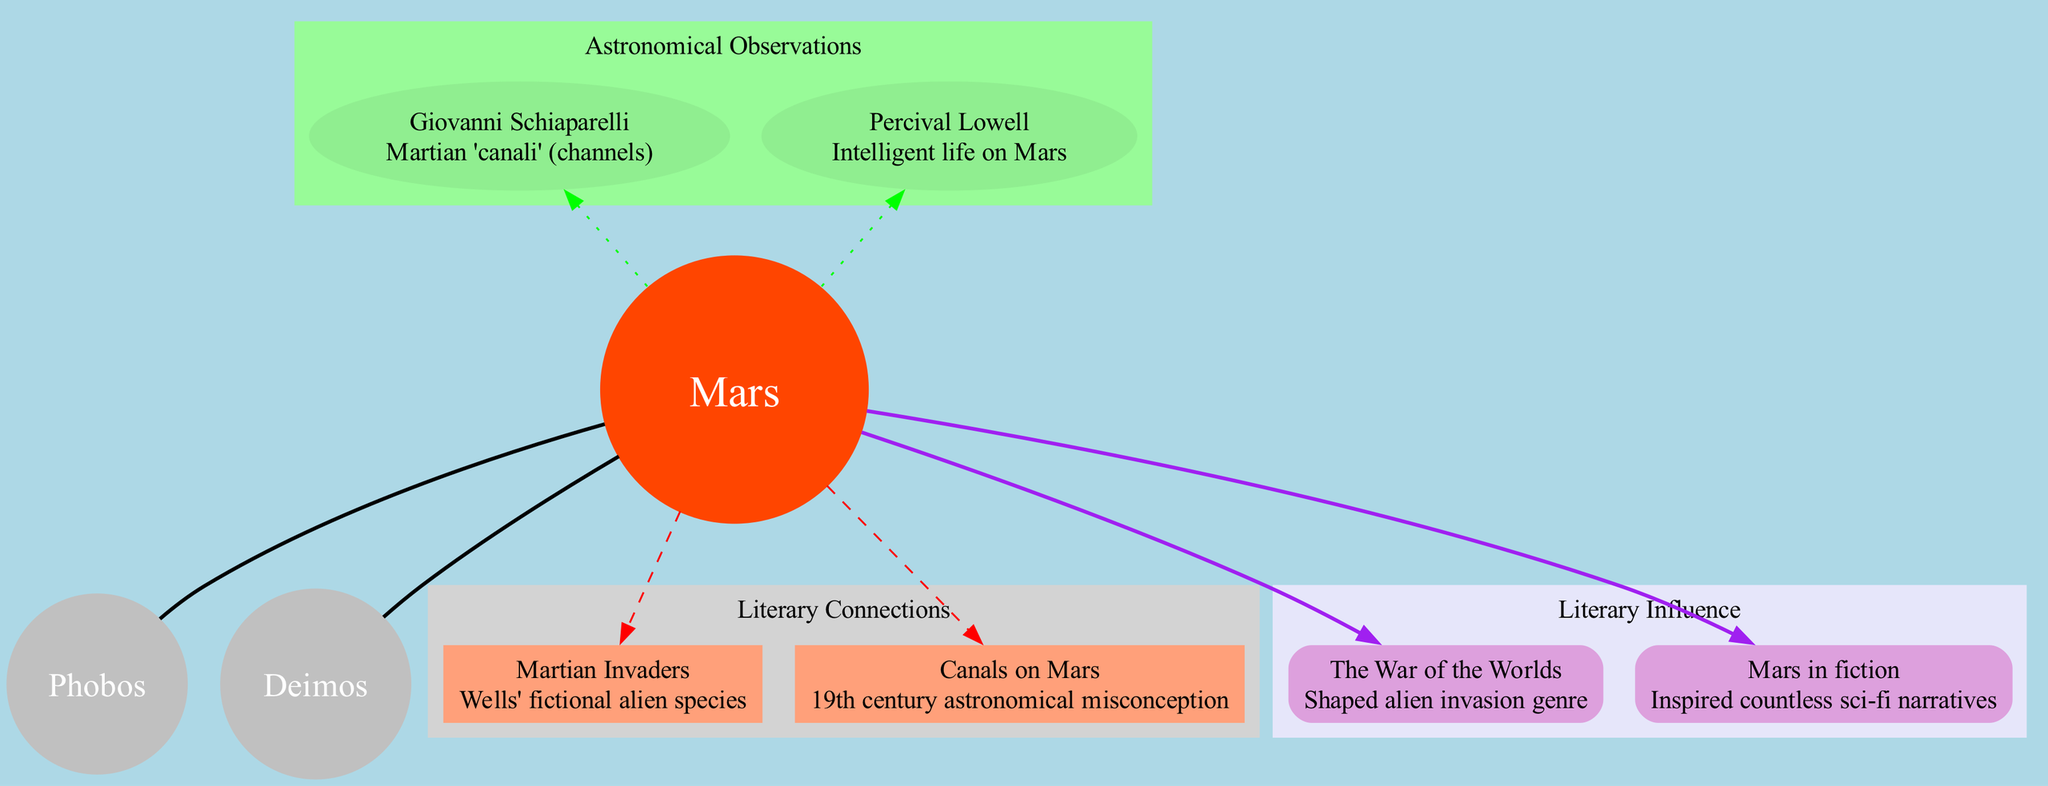What is the central object depicted in the diagram? The diagram indicates that Mars is positioned at the center, making it the central object.
Answer: Mars How many moons of Mars are shown in the diagram? The diagram lists two celestial bodies identified as moons of Mars, Phobos and Deimos.
Answer: 2 What literary connection is represented by the element "Canals on Mars"? This element refers to 19th-century astronomical misconceptions about Mars, which is explicitly stated in the description accompanying it.
Answer: 19th century astronomical misconception Who observed the Martian "canali"? The diagram specifies Giovanni Schiaparelli as the observer associated with the discovery of Martian "canali."
Answer: Giovanni Schiaparelli What type of relationship exists between Mars and its moons? The diagram illustrates a direct relationship, indicated by solid edges connecting Mars to its moons, which identifies them as celestial bodies orbiting Mars.
Answer: Direct relationship What impact did "The War of the Worlds" have on the alien invasion genre? The diagram asserts that "The War of the Worlds" significantly shaped the alien invasion genre, emphasizing its influence in literature.
Answer: Shaped alien invasion genre Which observer proposed the theory of intelligent life on Mars? The diagram attributes the theory of intelligent life on Mars to Percival Lowell, making this clear through the associated observation node.
Answer: Percival Lowell How are the literary connections visually distinguished in the diagram? The literary connections are shown in a specific subgraph with a filled light gray background, indicating their unique cluster and relationship to Mars.
Answer: Light gray background What color are the nodes representing the moons of Mars? The moons of Mars are represented as gray nodes in the diagram, as indicated by their designated color.
Answer: Gray Which element describes Wells' fictional alien species? The diagram mentions "Martian Invaders" as the element that describes Wells' fictional alien species.
Answer: Martian Invaders 